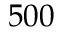Convert formula to latex. <formula><loc_0><loc_0><loc_500><loc_500>5 0 0</formula> 